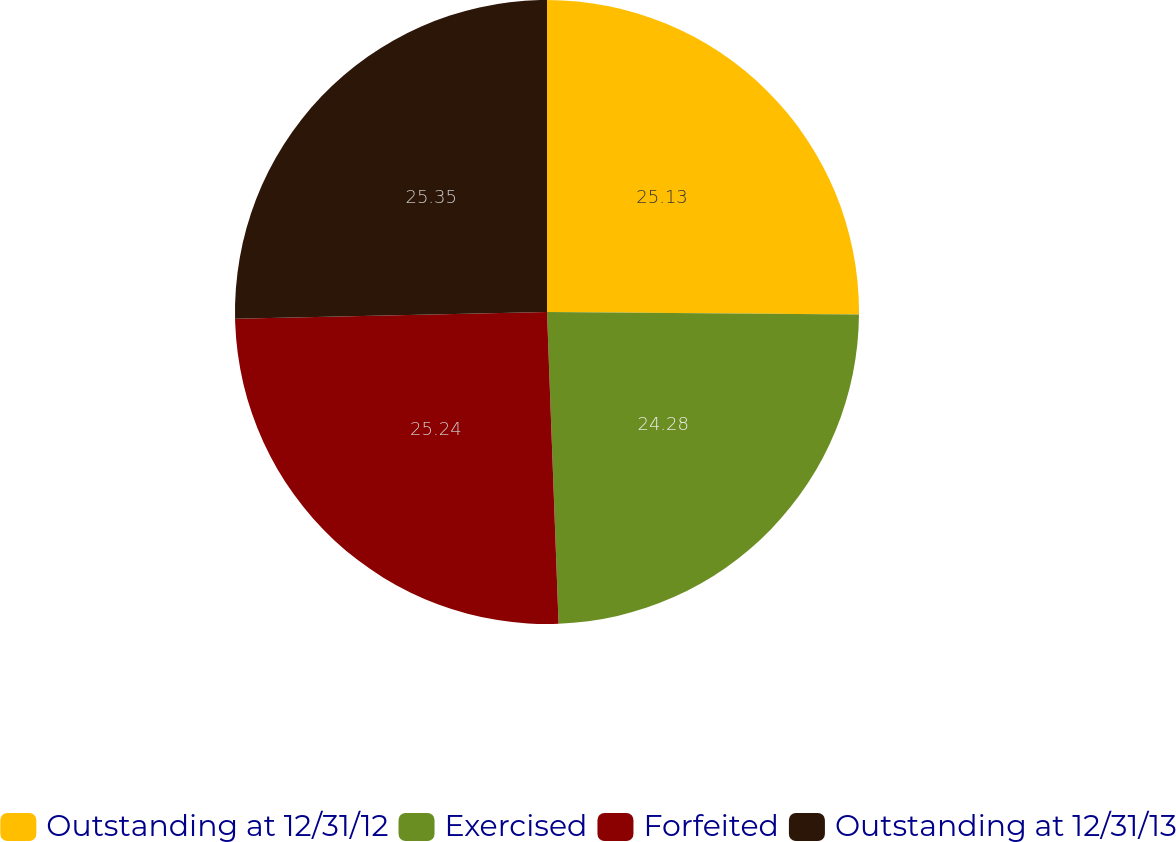<chart> <loc_0><loc_0><loc_500><loc_500><pie_chart><fcel>Outstanding at 12/31/12<fcel>Exercised<fcel>Forfeited<fcel>Outstanding at 12/31/13<nl><fcel>25.13%<fcel>24.28%<fcel>25.24%<fcel>25.35%<nl></chart> 